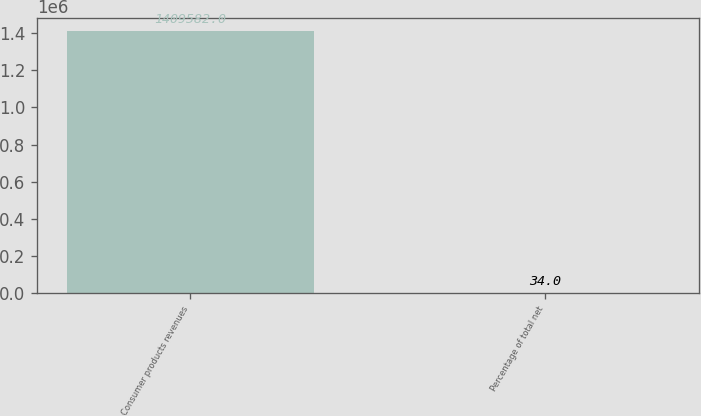Convert chart. <chart><loc_0><loc_0><loc_500><loc_500><bar_chart><fcel>Consumer products revenues<fcel>Percentage of total net<nl><fcel>1.40958e+06<fcel>34<nl></chart> 